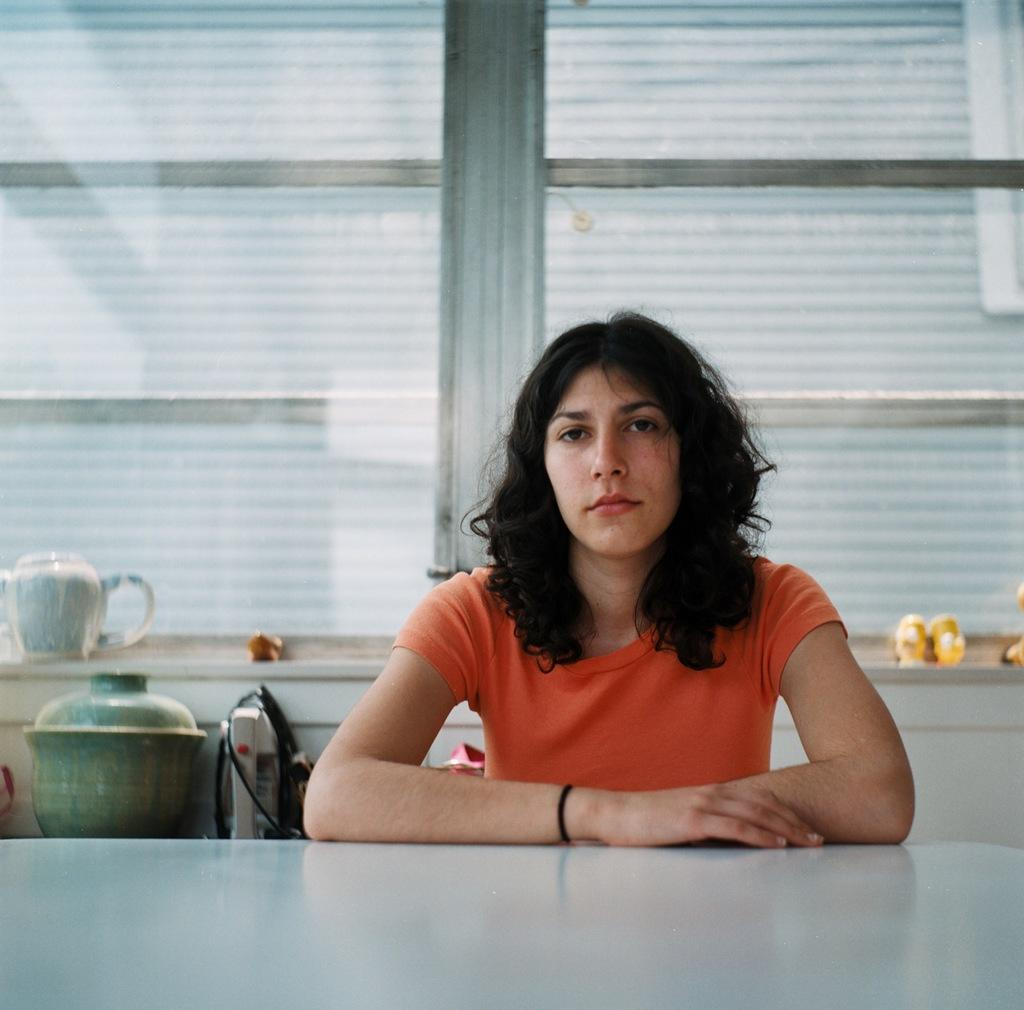Who is the main subject in the image? There is a lady in the image. What can be seen on the wall in the image? There are objects placed on the wall in the image. What is visible behind the person in the image? There are many objects visible behind the person in the image. How does the lady rub the crack in the image? There is no crack or rubbing action depicted in the image; it only shows a lady and objects on the wall. 